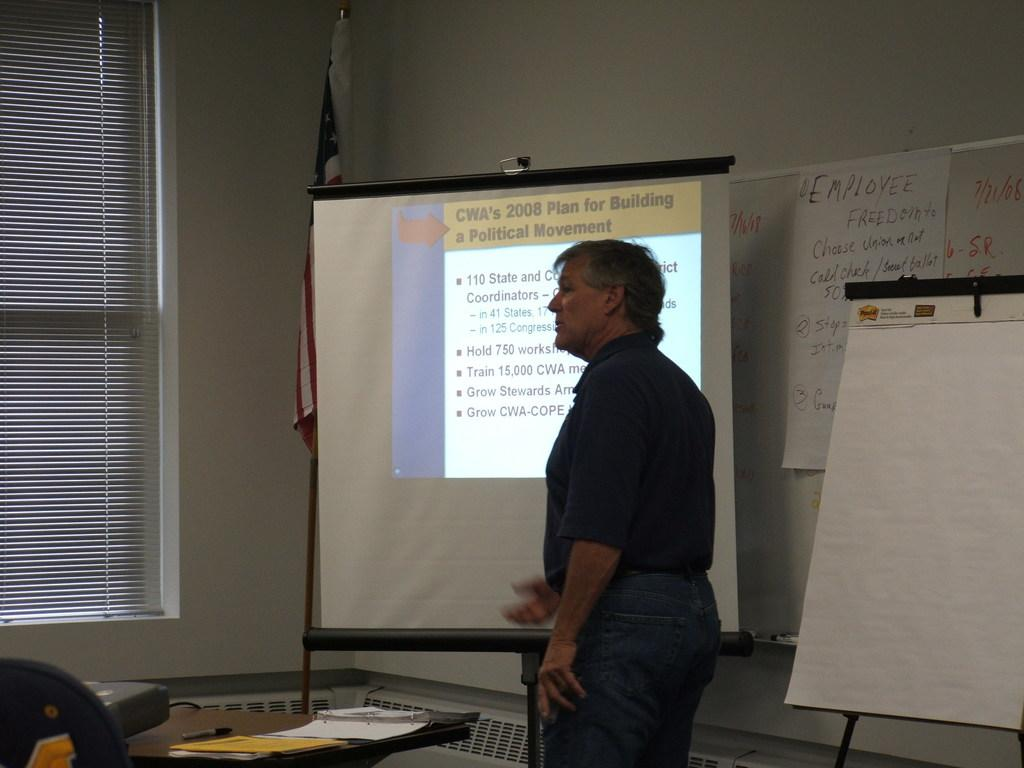<image>
Present a compact description of the photo's key features. A person is standing in front of a screen discussing a 2008 political movement. 